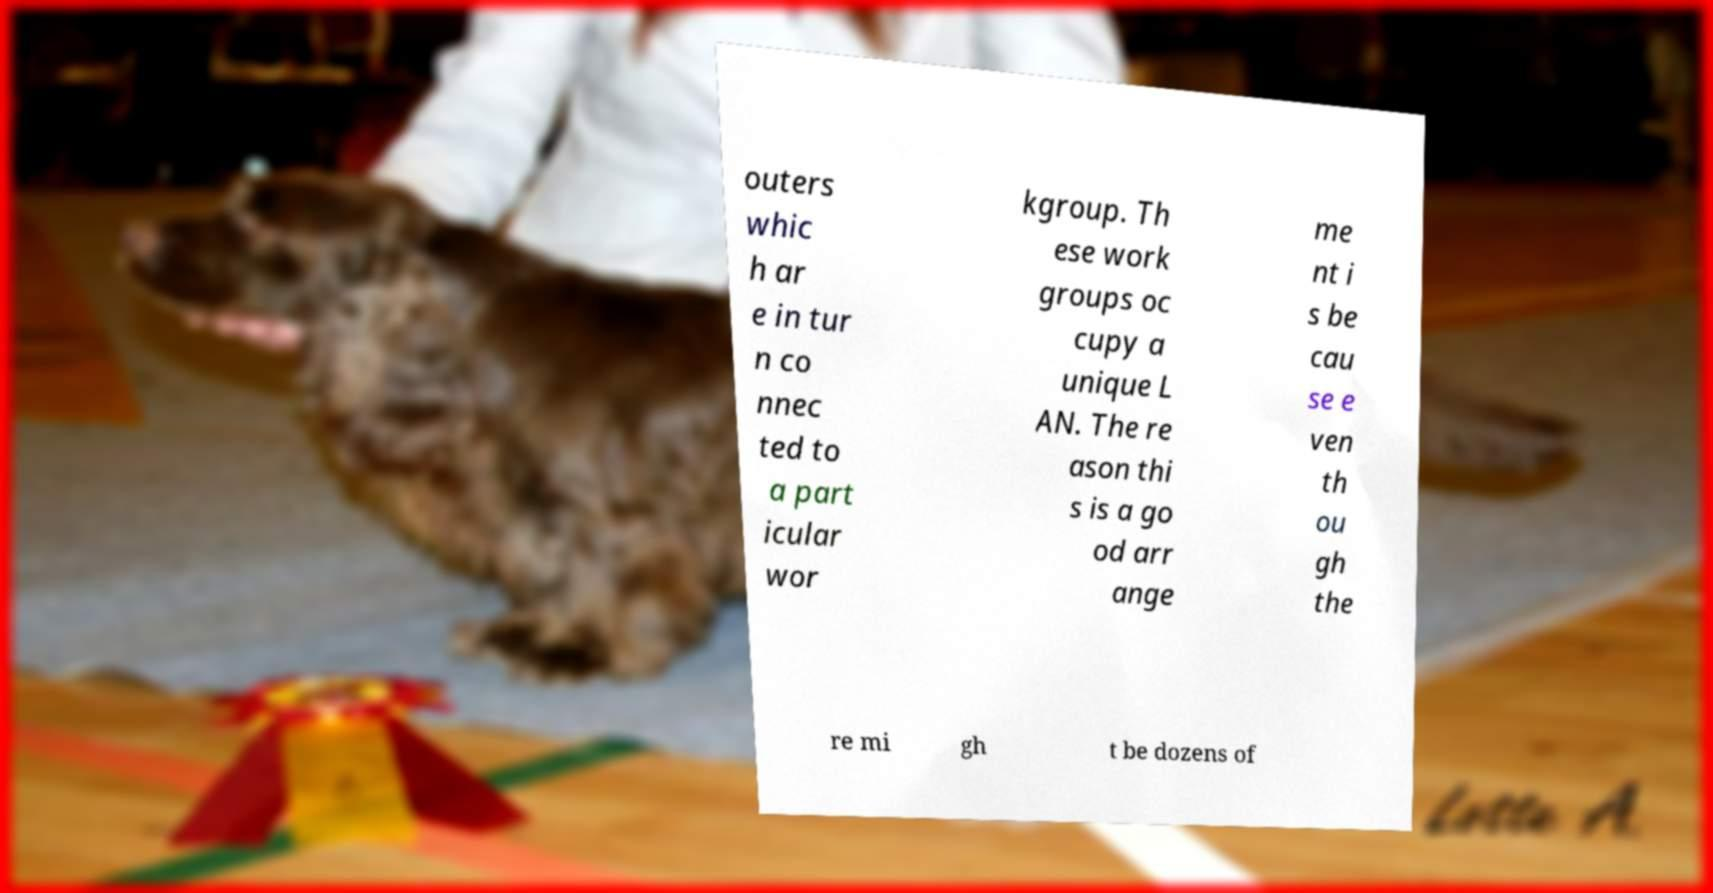Please identify and transcribe the text found in this image. outers whic h ar e in tur n co nnec ted to a part icular wor kgroup. Th ese work groups oc cupy a unique L AN. The re ason thi s is a go od arr ange me nt i s be cau se e ven th ou gh the re mi gh t be dozens of 